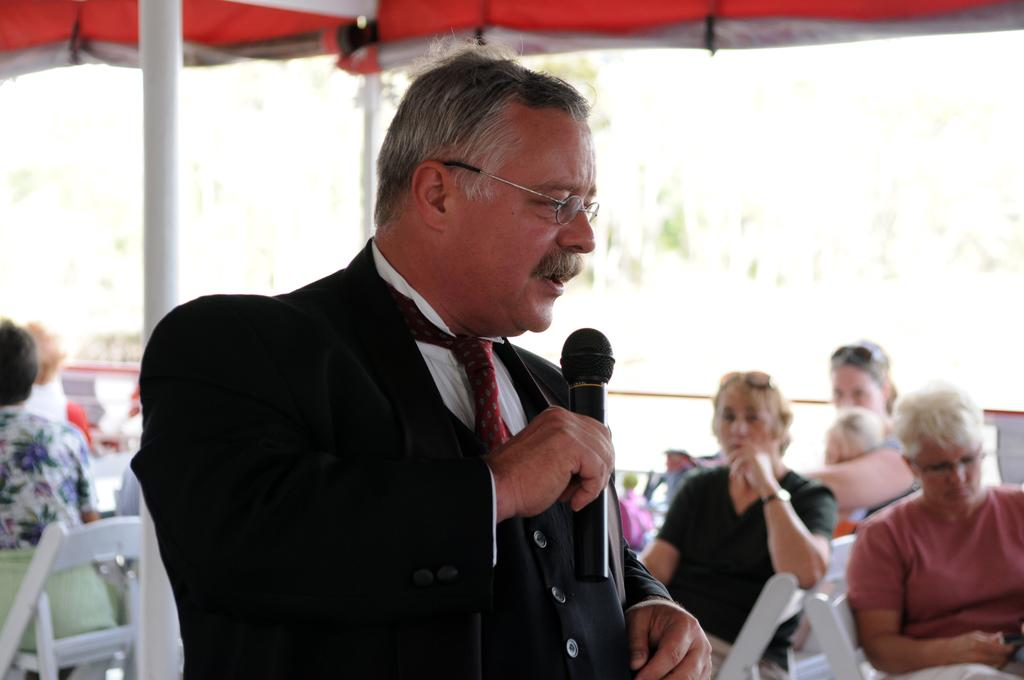What is the man in the image doing? The man is speaking into a microphone. How is the man holding the microphone? The microphone is in the man's hand. What are the other people in the image doing? The people are sitting on chairs. Can you describe the setting of the image? The man is speaking into a microphone, and there is a group of people sitting on chairs, which suggests a presentation or event. What type of structure is visible under the man's veil in the image? There is no veil present in the image, and the man is not wearing any structure under his veil. 